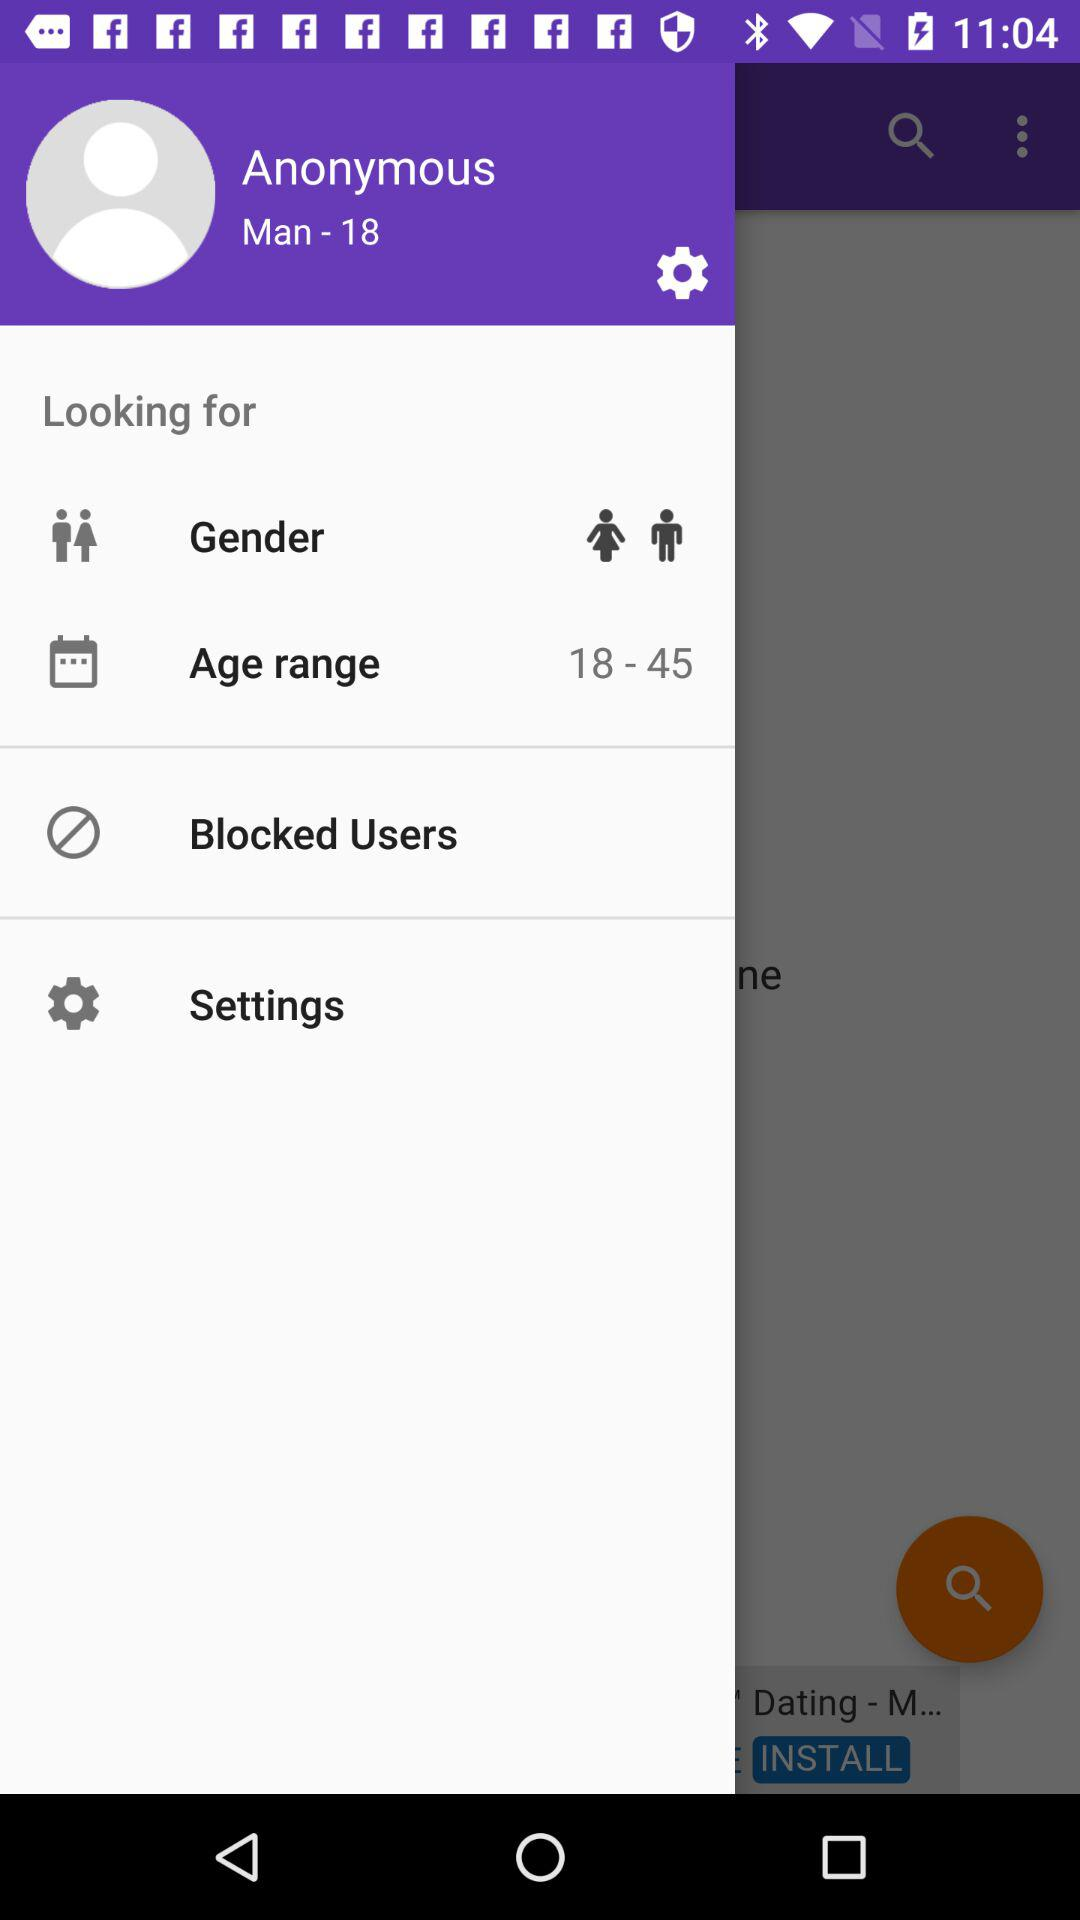What is the gender? The user is a man. 